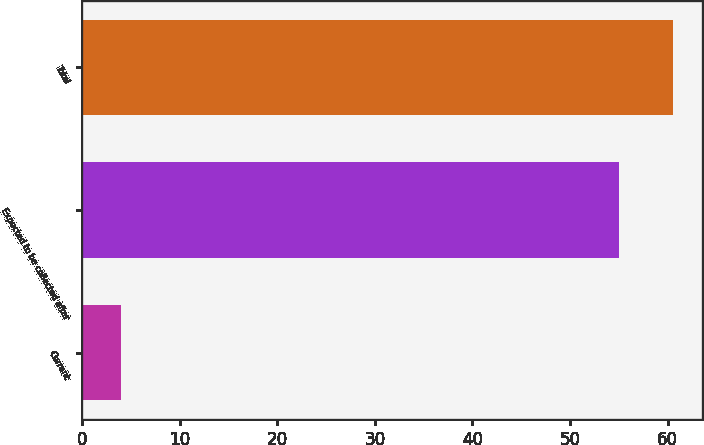Convert chart to OTSL. <chart><loc_0><loc_0><loc_500><loc_500><bar_chart><fcel>Current<fcel>Expected to be collected after<fcel>Total<nl><fcel>4<fcel>55<fcel>60.5<nl></chart> 